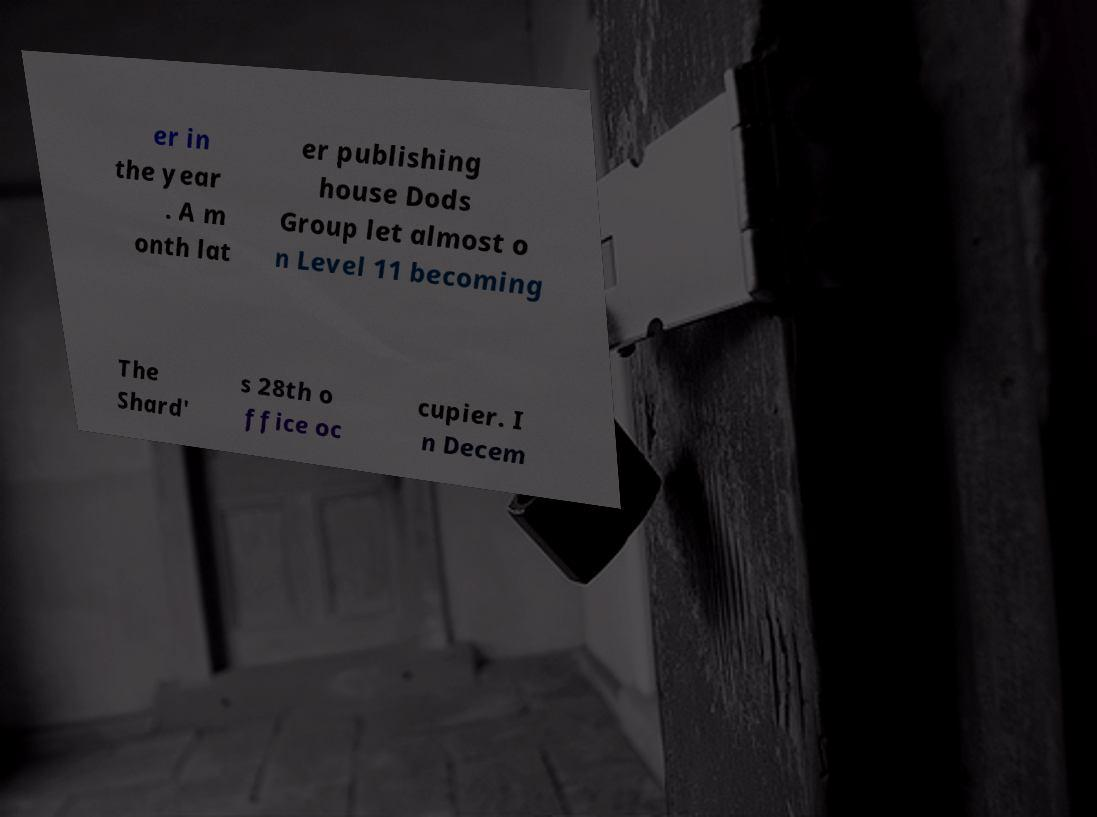Can you read and provide the text displayed in the image?This photo seems to have some interesting text. Can you extract and type it out for me? er in the year . A m onth lat er publishing house Dods Group let almost o n Level 11 becoming The Shard' s 28th o ffice oc cupier. I n Decem 